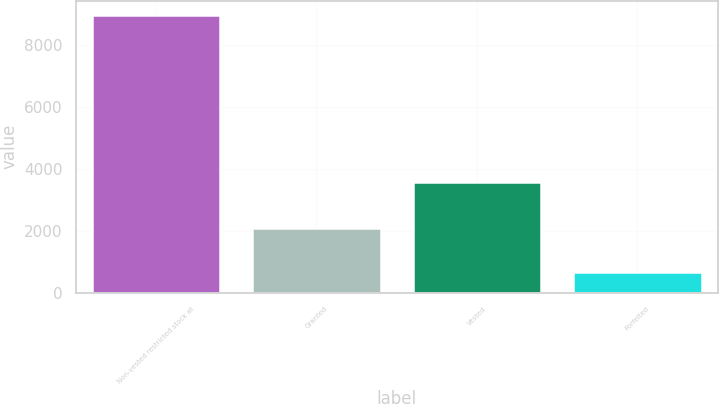Convert chart to OTSL. <chart><loc_0><loc_0><loc_500><loc_500><bar_chart><fcel>Non-vested restricted stock at<fcel>Granted<fcel>Vested<fcel>Forfeited<nl><fcel>8995<fcel>2090<fcel>3576<fcel>674<nl></chart> 